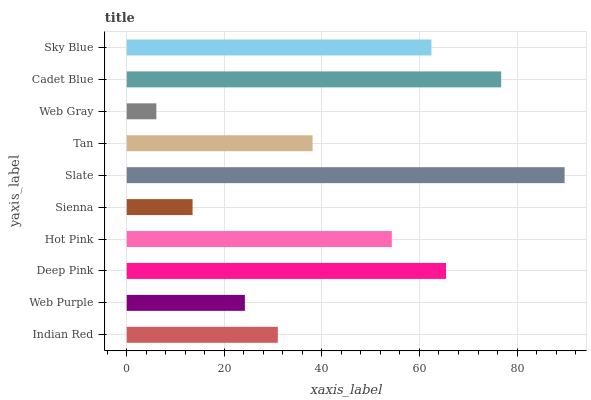Is Web Gray the minimum?
Answer yes or no. Yes. Is Slate the maximum?
Answer yes or no. Yes. Is Web Purple the minimum?
Answer yes or no. No. Is Web Purple the maximum?
Answer yes or no. No. Is Indian Red greater than Web Purple?
Answer yes or no. Yes. Is Web Purple less than Indian Red?
Answer yes or no. Yes. Is Web Purple greater than Indian Red?
Answer yes or no. No. Is Indian Red less than Web Purple?
Answer yes or no. No. Is Hot Pink the high median?
Answer yes or no. Yes. Is Tan the low median?
Answer yes or no. Yes. Is Cadet Blue the high median?
Answer yes or no. No. Is Web Purple the low median?
Answer yes or no. No. 